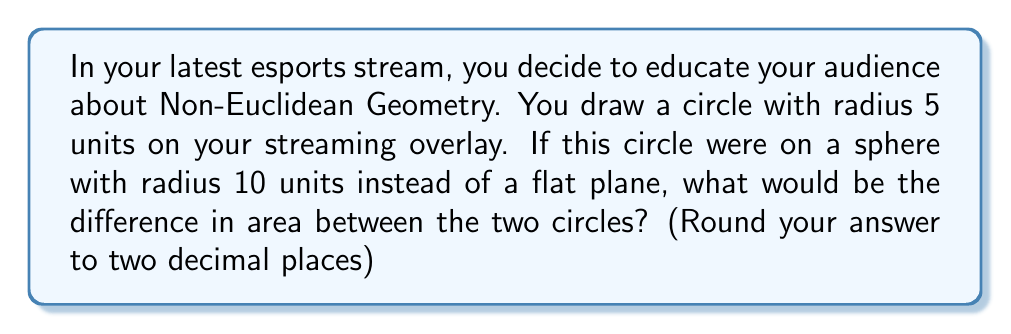Can you answer this question? Let's approach this step-by-step:

1) First, we need to calculate the area of the circle on a flat plane:
   $$A_{flat} = \pi r^2 = \pi (5)^2 = 25\pi$$

2) Now, for the circle on a sphere, we need to use the formula for the area of a spherical cap:
   $$A_{sphere} = 2\pi R h$$
   where R is the radius of the sphere and h is the height of the cap.

3) To find h, we can use the formula:
   $$h = R - R\cos\theta$$
   where $\theta$ is the central angle in radians.

4) We can find $\theta$ using the arc length formula:
   $$s = R\theta$$
   where s is the arc length (which is the circumference of our original circle).

5) The circumference of our original circle is:
   $$s = 2\pi r = 2\pi(5) = 10\pi$$

6) Now we can solve for $\theta$:
   $$10\pi = 10\theta$$
   $$\theta = \pi$$

7) With $\theta$, we can now find h:
   $$h = 10 - 10\cos(\pi) = 10 - 10(-1) = 20$$

8) Now we can calculate the area on the sphere:
   $$A_{sphere} = 2\pi(10)(20) = 400\pi$$

9) The difference in area is:
   $$A_{sphere} - A_{flat} = 400\pi - 25\pi = 375\pi$$

10) Converting to a decimal and rounding to two places:
    $$375\pi \approx 1178.10$$
Answer: 1178.10 square units 